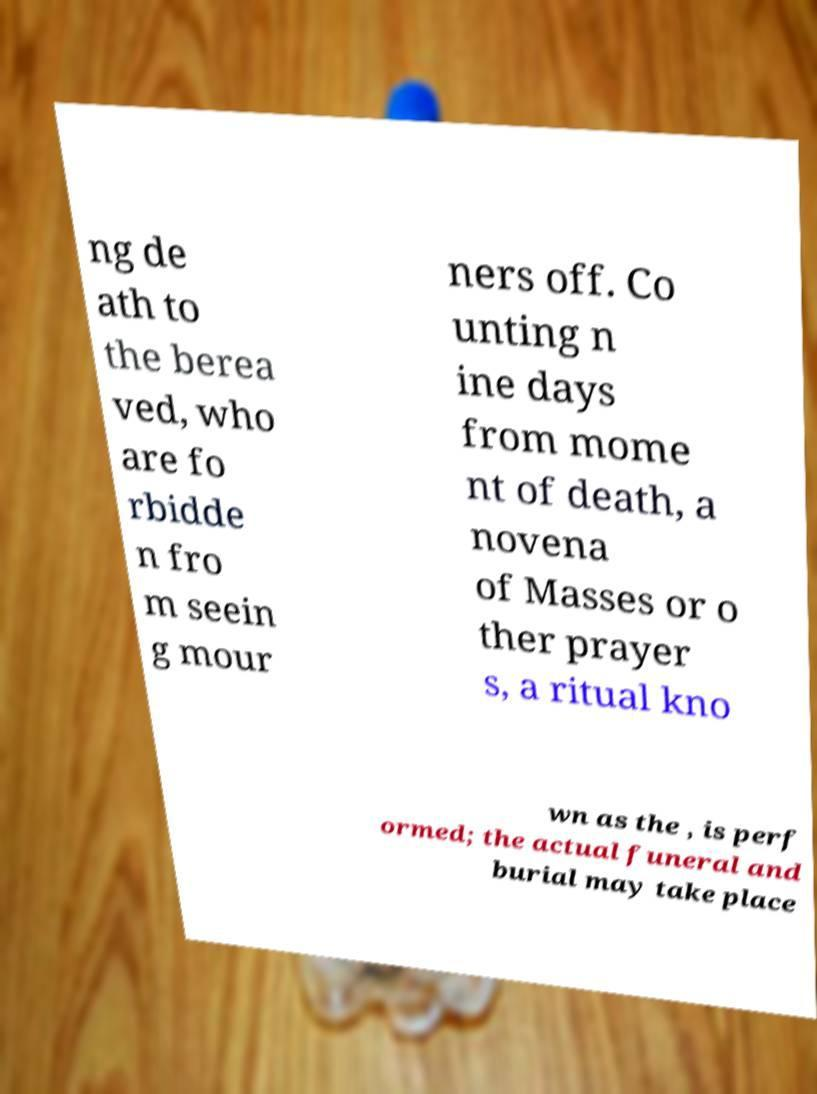Could you assist in decoding the text presented in this image and type it out clearly? ng de ath to the berea ved, who are fo rbidde n fro m seein g mour ners off. Co unting n ine days from mome nt of death, a novena of Masses or o ther prayer s, a ritual kno wn as the , is perf ormed; the actual funeral and burial may take place 